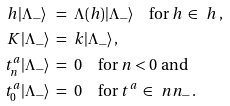Convert formula to latex. <formula><loc_0><loc_0><loc_500><loc_500>h | \Lambda _ { - } \rangle \ & = \ \Lambda ( h ) | \Lambda _ { - } \rangle \quad \text {for} \ h \, \in \, \ h \, , \\ K | \Lambda _ { - } \rangle \ & = \ k | \Lambda _ { - } \rangle \, , \\ t ^ { a } _ { n } | \Lambda _ { - } \rangle \ & = \ 0 \quad \text {for} \ n < 0 \ \text {and} \\ t ^ { a } _ { 0 } | \Lambda _ { - } \rangle \ & = \ 0 \quad \text {for} \ t ^ { a } \, \in \, \ n n _ { - } \, . \\</formula> 